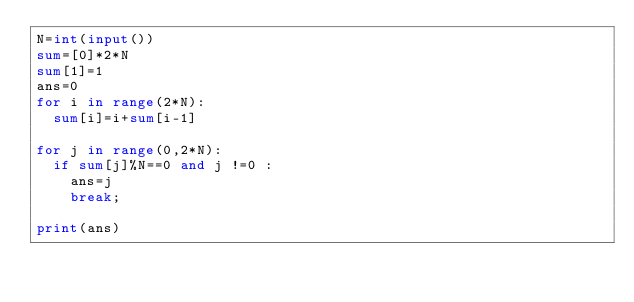<code> <loc_0><loc_0><loc_500><loc_500><_Python_>N=int(input())
sum=[0]*2*N
sum[1]=1
ans=0
for i in range(2*N):
  sum[i]=i+sum[i-1]
  
for j in range(0,2*N):
  if sum[j]%N==0 and j !=0 :
    ans=j
    break;
    
print(ans)</code> 